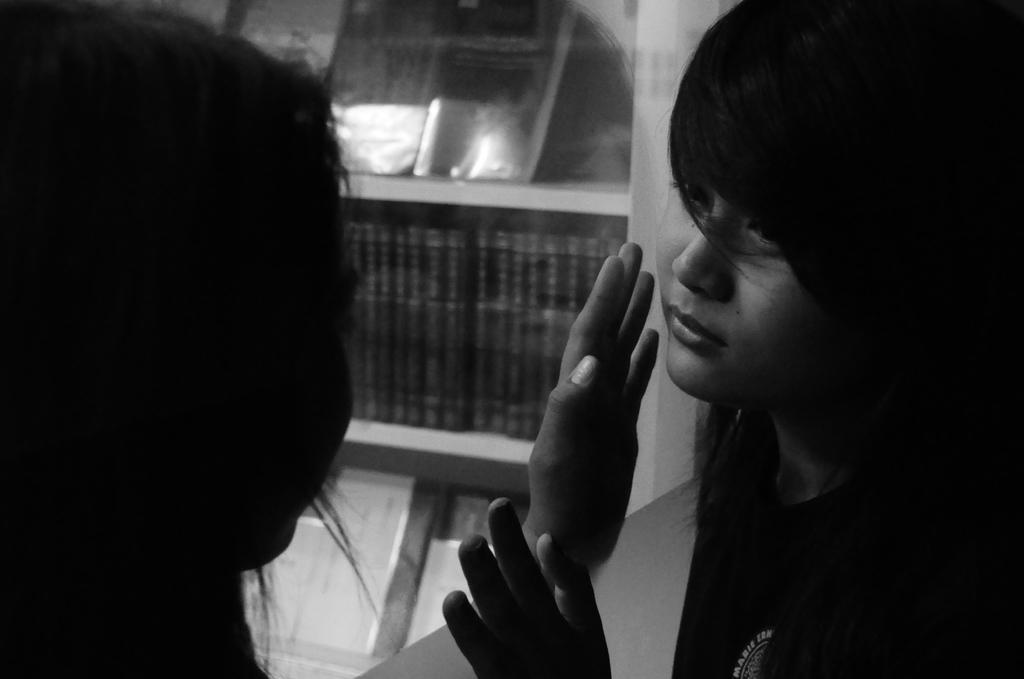Could you give a brief overview of what you see in this image? This is a black and white image. In this image we can see two persons standing in the opposite direction. On the backside we can see some books in the shelves. 